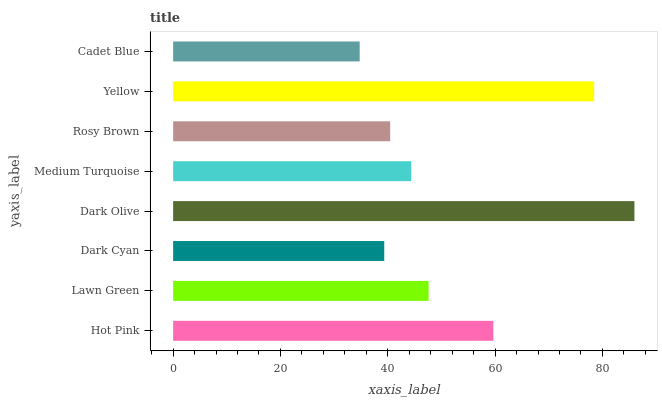Is Cadet Blue the minimum?
Answer yes or no. Yes. Is Dark Olive the maximum?
Answer yes or no. Yes. Is Lawn Green the minimum?
Answer yes or no. No. Is Lawn Green the maximum?
Answer yes or no. No. Is Hot Pink greater than Lawn Green?
Answer yes or no. Yes. Is Lawn Green less than Hot Pink?
Answer yes or no. Yes. Is Lawn Green greater than Hot Pink?
Answer yes or no. No. Is Hot Pink less than Lawn Green?
Answer yes or no. No. Is Lawn Green the high median?
Answer yes or no. Yes. Is Medium Turquoise the low median?
Answer yes or no. Yes. Is Medium Turquoise the high median?
Answer yes or no. No. Is Yellow the low median?
Answer yes or no. No. 